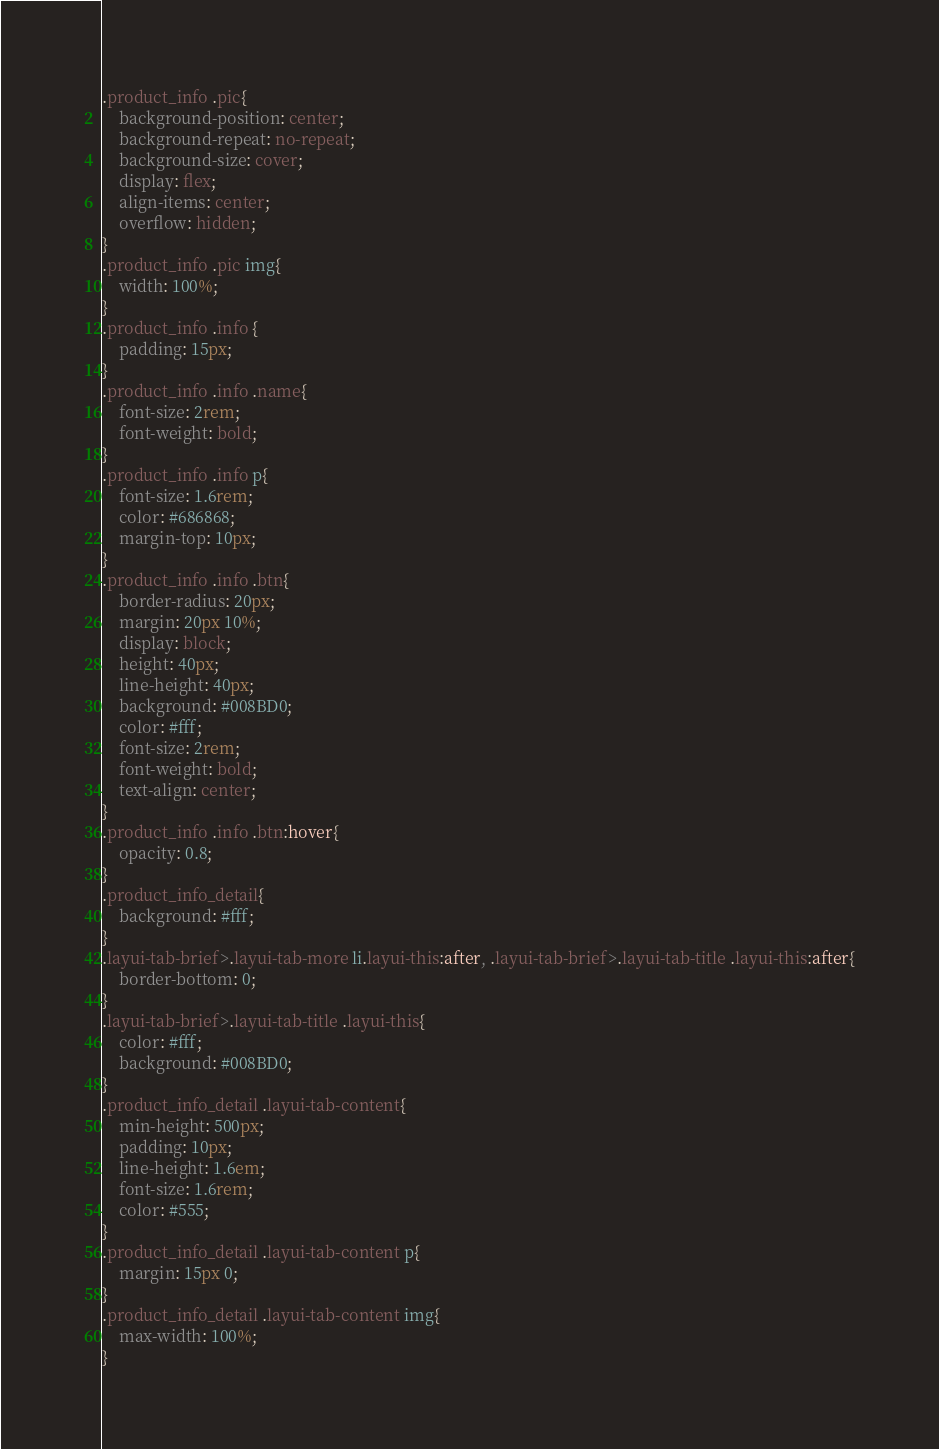<code> <loc_0><loc_0><loc_500><loc_500><_CSS_>.product_info .pic{
	background-position: center;
	background-repeat: no-repeat;
	background-size: cover;
	display: flex;
	align-items: center;
	overflow: hidden;
}
.product_info .pic img{
	width: 100%;
}
.product_info .info {
	padding: 15px;
}
.product_info .info .name{
	font-size: 2rem;
	font-weight: bold;
}
.product_info .info p{
	font-size: 1.6rem;
	color: #686868;
	margin-top: 10px;
}
.product_info .info .btn{
	border-radius: 20px;
	margin: 20px 10%;
	display: block;
	height: 40px;
	line-height: 40px;
	background: #008BD0;
	color: #fff;
	font-size: 2rem;
	font-weight: bold;
	text-align: center;
}
.product_info .info .btn:hover{
	opacity: 0.8;
}
.product_info_detail{
	background: #fff;
}
.layui-tab-brief>.layui-tab-more li.layui-this:after, .layui-tab-brief>.layui-tab-title .layui-this:after{
	border-bottom: 0;
}
.layui-tab-brief>.layui-tab-title .layui-this{
	color: #fff;
	background: #008BD0;
}
.product_info_detail .layui-tab-content{
	min-height: 500px;
	padding: 10px;
	line-height: 1.6em;
	font-size: 1.6rem;
	color: #555;
}
.product_info_detail .layui-tab-content p{
	margin: 15px 0;
}
.product_info_detail .layui-tab-content img{
	max-width: 100%;
}
</code> 